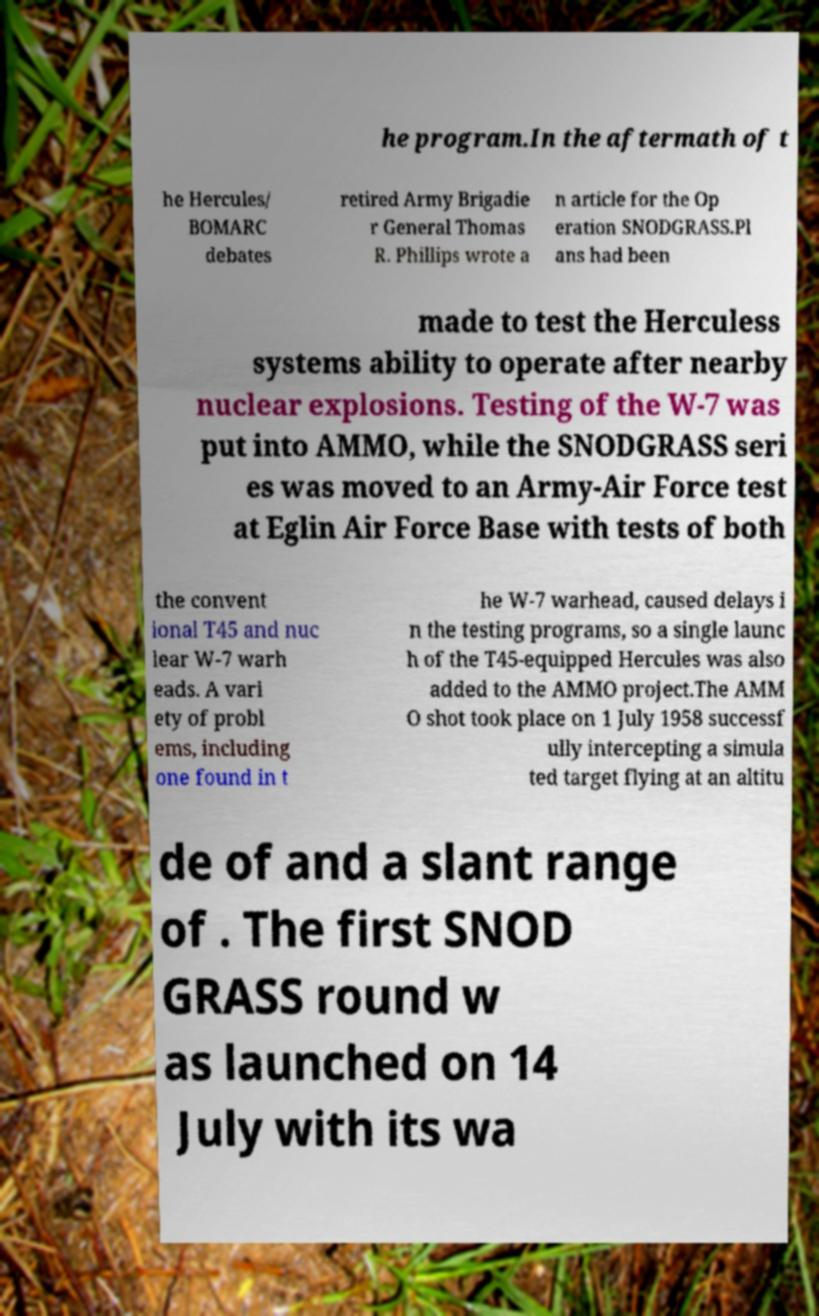Please read and relay the text visible in this image. What does it say? he program.In the aftermath of t he Hercules/ BOMARC debates retired Army Brigadie r General Thomas R. Phillips wrote a n article for the Op eration SNODGRASS.Pl ans had been made to test the Herculess systems ability to operate after nearby nuclear explosions. Testing of the W-7 was put into AMMO, while the SNODGRASS seri es was moved to an Army-Air Force test at Eglin Air Force Base with tests of both the convent ional T45 and nuc lear W-7 warh eads. A vari ety of probl ems, including one found in t he W-7 warhead, caused delays i n the testing programs, so a single launc h of the T45-equipped Hercules was also added to the AMMO project.The AMM O shot took place on 1 July 1958 successf ully intercepting a simula ted target flying at an altitu de of and a slant range of . The first SNOD GRASS round w as launched on 14 July with its wa 